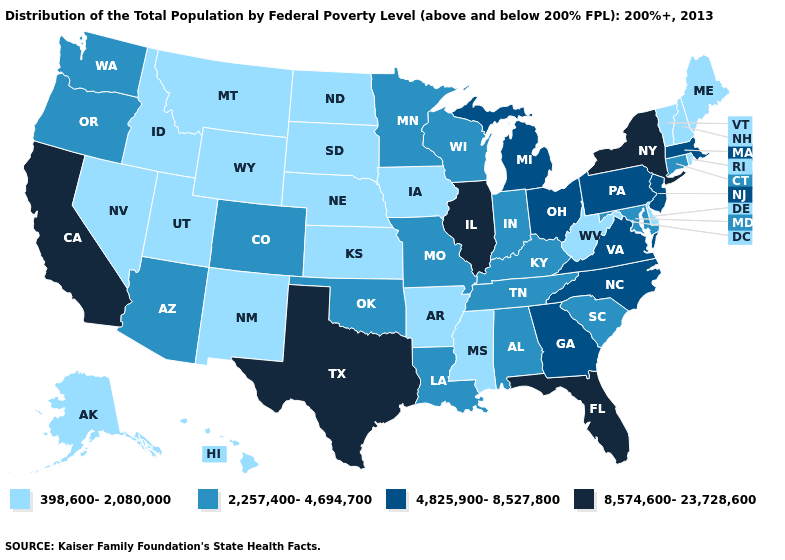Which states have the lowest value in the South?
Quick response, please. Arkansas, Delaware, Mississippi, West Virginia. Does Indiana have the highest value in the USA?
Concise answer only. No. Does the map have missing data?
Be succinct. No. What is the value of Rhode Island?
Short answer required. 398,600-2,080,000. What is the lowest value in the USA?
Concise answer only. 398,600-2,080,000. Does Florida have the highest value in the South?
Short answer required. Yes. What is the value of Oregon?
Keep it brief. 2,257,400-4,694,700. Does Georgia have the lowest value in the South?
Be succinct. No. What is the highest value in the USA?
Keep it brief. 8,574,600-23,728,600. Name the states that have a value in the range 2,257,400-4,694,700?
Be succinct. Alabama, Arizona, Colorado, Connecticut, Indiana, Kentucky, Louisiana, Maryland, Minnesota, Missouri, Oklahoma, Oregon, South Carolina, Tennessee, Washington, Wisconsin. What is the value of Minnesota?
Give a very brief answer. 2,257,400-4,694,700. Does Massachusetts have a lower value than New York?
Concise answer only. Yes. What is the value of Michigan?
Answer briefly. 4,825,900-8,527,800. Which states have the lowest value in the USA?
Short answer required. Alaska, Arkansas, Delaware, Hawaii, Idaho, Iowa, Kansas, Maine, Mississippi, Montana, Nebraska, Nevada, New Hampshire, New Mexico, North Dakota, Rhode Island, South Dakota, Utah, Vermont, West Virginia, Wyoming. What is the value of Florida?
Be succinct. 8,574,600-23,728,600. 